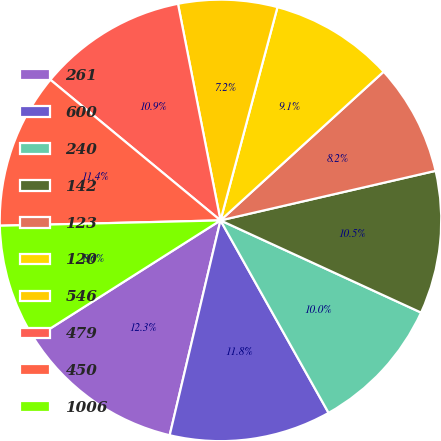Convert chart to OTSL. <chart><loc_0><loc_0><loc_500><loc_500><pie_chart><fcel>261<fcel>600<fcel>240<fcel>142<fcel>123<fcel>120<fcel>546<fcel>479<fcel>450<fcel>1006<nl><fcel>12.3%<fcel>11.84%<fcel>10.0%<fcel>10.46%<fcel>8.16%<fcel>9.08%<fcel>7.24%<fcel>10.92%<fcel>11.38%<fcel>8.62%<nl></chart> 